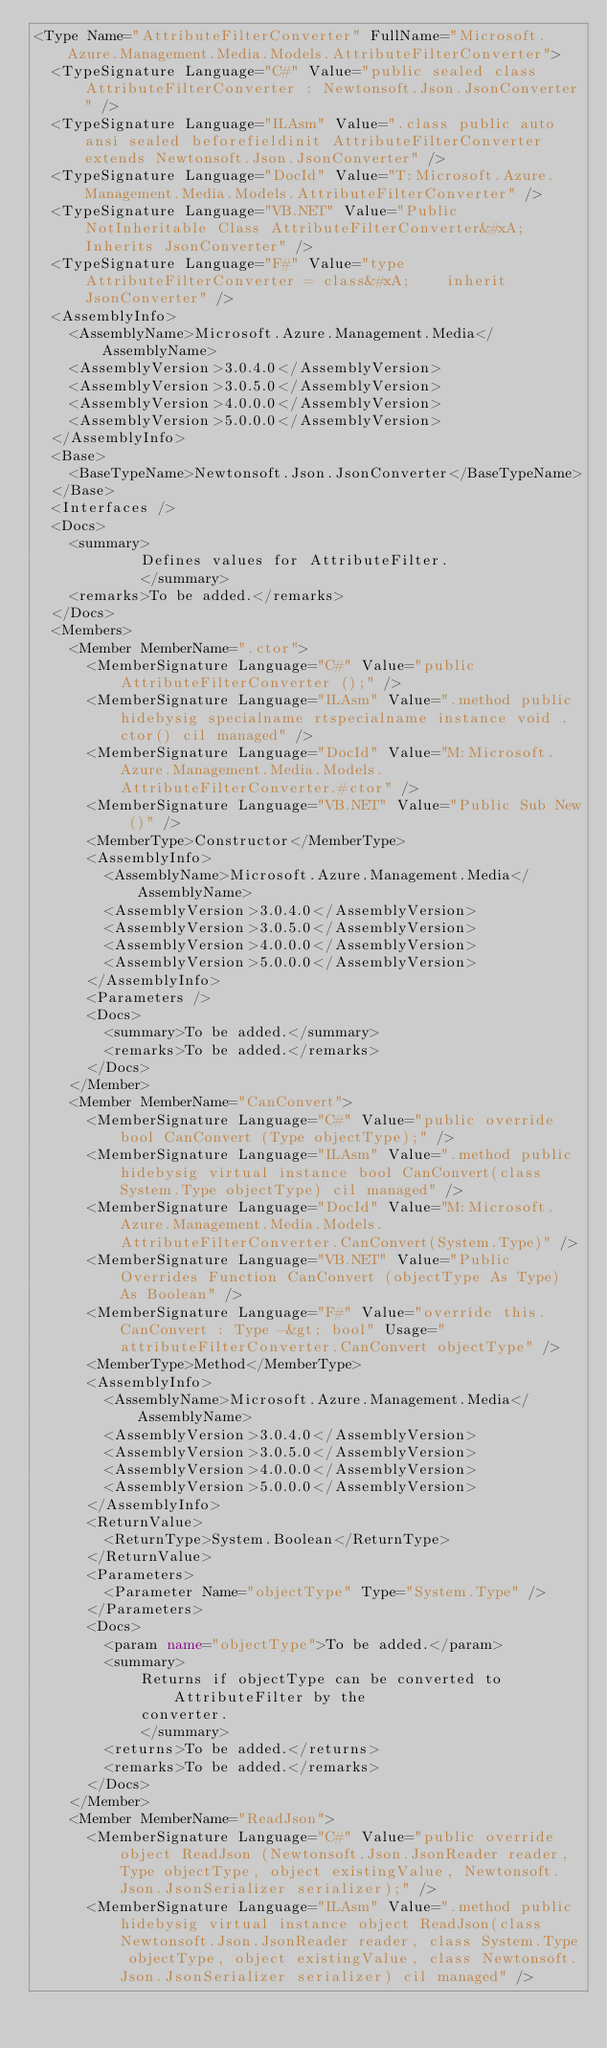<code> <loc_0><loc_0><loc_500><loc_500><_XML_><Type Name="AttributeFilterConverter" FullName="Microsoft.Azure.Management.Media.Models.AttributeFilterConverter">
  <TypeSignature Language="C#" Value="public sealed class AttributeFilterConverter : Newtonsoft.Json.JsonConverter" />
  <TypeSignature Language="ILAsm" Value=".class public auto ansi sealed beforefieldinit AttributeFilterConverter extends Newtonsoft.Json.JsonConverter" />
  <TypeSignature Language="DocId" Value="T:Microsoft.Azure.Management.Media.Models.AttributeFilterConverter" />
  <TypeSignature Language="VB.NET" Value="Public NotInheritable Class AttributeFilterConverter&#xA;Inherits JsonConverter" />
  <TypeSignature Language="F#" Value="type AttributeFilterConverter = class&#xA;    inherit JsonConverter" />
  <AssemblyInfo>
    <AssemblyName>Microsoft.Azure.Management.Media</AssemblyName>
    <AssemblyVersion>3.0.4.0</AssemblyVersion>
    <AssemblyVersion>3.0.5.0</AssemblyVersion>
    <AssemblyVersion>4.0.0.0</AssemblyVersion>
    <AssemblyVersion>5.0.0.0</AssemblyVersion>
  </AssemblyInfo>
  <Base>
    <BaseTypeName>Newtonsoft.Json.JsonConverter</BaseTypeName>
  </Base>
  <Interfaces />
  <Docs>
    <summary>
            Defines values for AttributeFilter.
            </summary>
    <remarks>To be added.</remarks>
  </Docs>
  <Members>
    <Member MemberName=".ctor">
      <MemberSignature Language="C#" Value="public AttributeFilterConverter ();" />
      <MemberSignature Language="ILAsm" Value=".method public hidebysig specialname rtspecialname instance void .ctor() cil managed" />
      <MemberSignature Language="DocId" Value="M:Microsoft.Azure.Management.Media.Models.AttributeFilterConverter.#ctor" />
      <MemberSignature Language="VB.NET" Value="Public Sub New ()" />
      <MemberType>Constructor</MemberType>
      <AssemblyInfo>
        <AssemblyName>Microsoft.Azure.Management.Media</AssemblyName>
        <AssemblyVersion>3.0.4.0</AssemblyVersion>
        <AssemblyVersion>3.0.5.0</AssemblyVersion>
        <AssemblyVersion>4.0.0.0</AssemblyVersion>
        <AssemblyVersion>5.0.0.0</AssemblyVersion>
      </AssemblyInfo>
      <Parameters />
      <Docs>
        <summary>To be added.</summary>
        <remarks>To be added.</remarks>
      </Docs>
    </Member>
    <Member MemberName="CanConvert">
      <MemberSignature Language="C#" Value="public override bool CanConvert (Type objectType);" />
      <MemberSignature Language="ILAsm" Value=".method public hidebysig virtual instance bool CanConvert(class System.Type objectType) cil managed" />
      <MemberSignature Language="DocId" Value="M:Microsoft.Azure.Management.Media.Models.AttributeFilterConverter.CanConvert(System.Type)" />
      <MemberSignature Language="VB.NET" Value="Public Overrides Function CanConvert (objectType As Type) As Boolean" />
      <MemberSignature Language="F#" Value="override this.CanConvert : Type -&gt; bool" Usage="attributeFilterConverter.CanConvert objectType" />
      <MemberType>Method</MemberType>
      <AssemblyInfo>
        <AssemblyName>Microsoft.Azure.Management.Media</AssemblyName>
        <AssemblyVersion>3.0.4.0</AssemblyVersion>
        <AssemblyVersion>3.0.5.0</AssemblyVersion>
        <AssemblyVersion>4.0.0.0</AssemblyVersion>
        <AssemblyVersion>5.0.0.0</AssemblyVersion>
      </AssemblyInfo>
      <ReturnValue>
        <ReturnType>System.Boolean</ReturnType>
      </ReturnValue>
      <Parameters>
        <Parameter Name="objectType" Type="System.Type" />
      </Parameters>
      <Docs>
        <param name="objectType">To be added.</param>
        <summary>
            Returns if objectType can be converted to AttributeFilter by the
            converter.
            </summary>
        <returns>To be added.</returns>
        <remarks>To be added.</remarks>
      </Docs>
    </Member>
    <Member MemberName="ReadJson">
      <MemberSignature Language="C#" Value="public override object ReadJson (Newtonsoft.Json.JsonReader reader, Type objectType, object existingValue, Newtonsoft.Json.JsonSerializer serializer);" />
      <MemberSignature Language="ILAsm" Value=".method public hidebysig virtual instance object ReadJson(class Newtonsoft.Json.JsonReader reader, class System.Type objectType, object existingValue, class Newtonsoft.Json.JsonSerializer serializer) cil managed" /></code> 